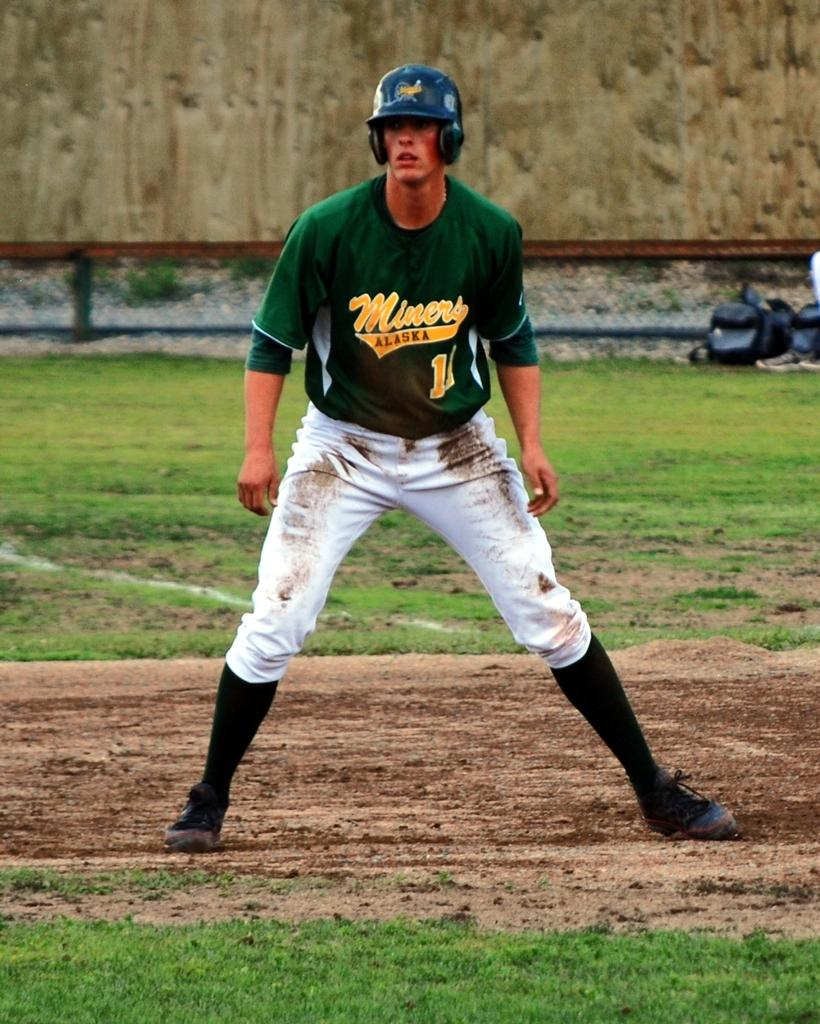<image>
Give a short and clear explanation of the subsequent image. The baseball player pictured is from the State of Alaska. 